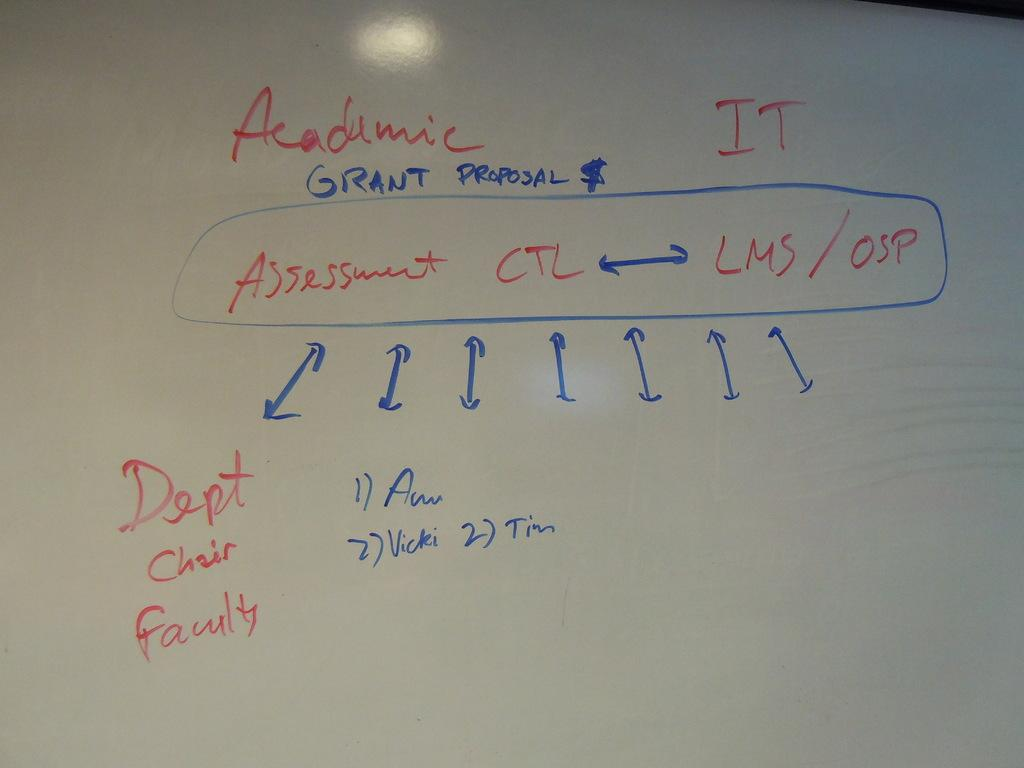<image>
Create a compact narrative representing the image presented. A dry erase board with a diagram for an Academic Grant Proposal. 